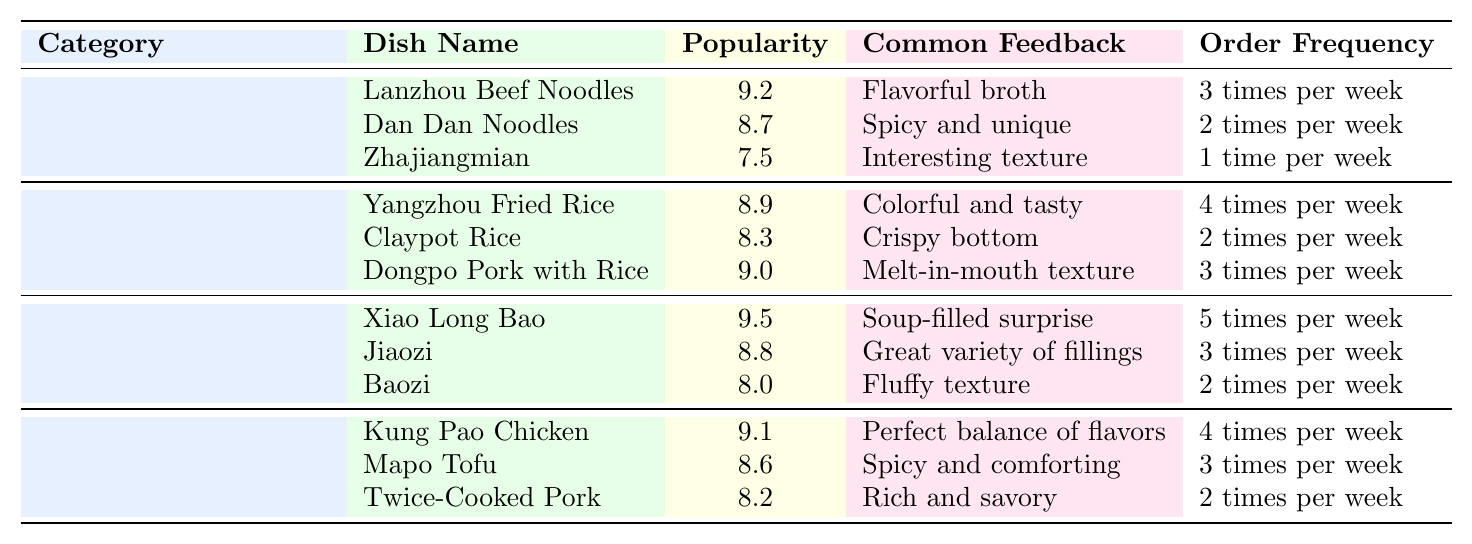What is the most popular noodle dish among foreign guests? The table shows that "Lanzhou Beef Noodles" has the highest popularity rating among noodle dishes with a score of 9.2.
Answer: Lanzhou Beef Noodles Which rice dish is ordered most frequently by foreign guests? In the table, "Yangzhou Fried Rice" is noted for having the highest order frequency at 4 times per week.
Answer: Yangzhou Fried Rice What is the average popularity rating of stir-fry dishes? The popularity ratings for stir-fry dishes are 9.1, 8.6, and 8.2. Adding these gives 26. The average is 26 divided by 3, which is approximately 8.67.
Answer: 8.67 Is "Xiao Long Bao" more popular than "Claypot Rice"? "Xiao Long Bao" has a popularity rating of 9.5, while "Claypot Rice" has a rating of 8.3, indicating that "Xiao Long Bao" is indeed more popular.
Answer: Yes What dish has the common feedback of being "spicy and unique"? The table indicates that "Dan Dan Noodles" is described with this feedback.
Answer: Dan Dan Noodles How many times per week is "Jiaozi" ordered compared to "Baozi"? "Jiaozi" is ordered 3 times per week, while "Baozi" is ordered 2 times per week. Therefore, "Jiaozi" is ordered 1 more time per week than "Baozi".
Answer: 1 time Which category has the highest average popularity rating and what is it? The average popularity ratings for each category are calculated as follows: Noodle Dishes: (9.2 + 8.7 + 7.5)/3 = 8.47, Rice Dishes: (8.9 + 8.3 + 9.0)/3 = 8.73, Dumplings and Buns: (9.5 + 8.8 + 8.0)/3 = 8.77, Stir-Fry Dishes: (9.1 + 8.6 + 8.2)/3 = 8.67. The category with the highest average is Rice Dishes with an average of 8.73.
Answer: Rice Dishes, 8.73 Which dish is ordered the least frequently in the rice dishes category? The table shows that "Claypot Rice" has the lowest order frequency at 2 times per week among rice dishes.
Answer: Claypot Rice Does "Twice-Cooked Pork" have a higher popularity rating than "Zhajiangmian"? "Twice-Cooked Pork" has a popularity rating of 8.2 and "Zhajiangmian" has a rating of 7.5, thus "Twice-Cooked Pork" does have a higher rating.
Answer: Yes What is the total order frequency for all dumpling and bun dishes per week? The order frequencies are 5 times for "Xiao Long Bao," 3 times for "Jiaozi," and 2 times for "Baozi." Summing these gives a total of 10 times per week.
Answer: 10 times 